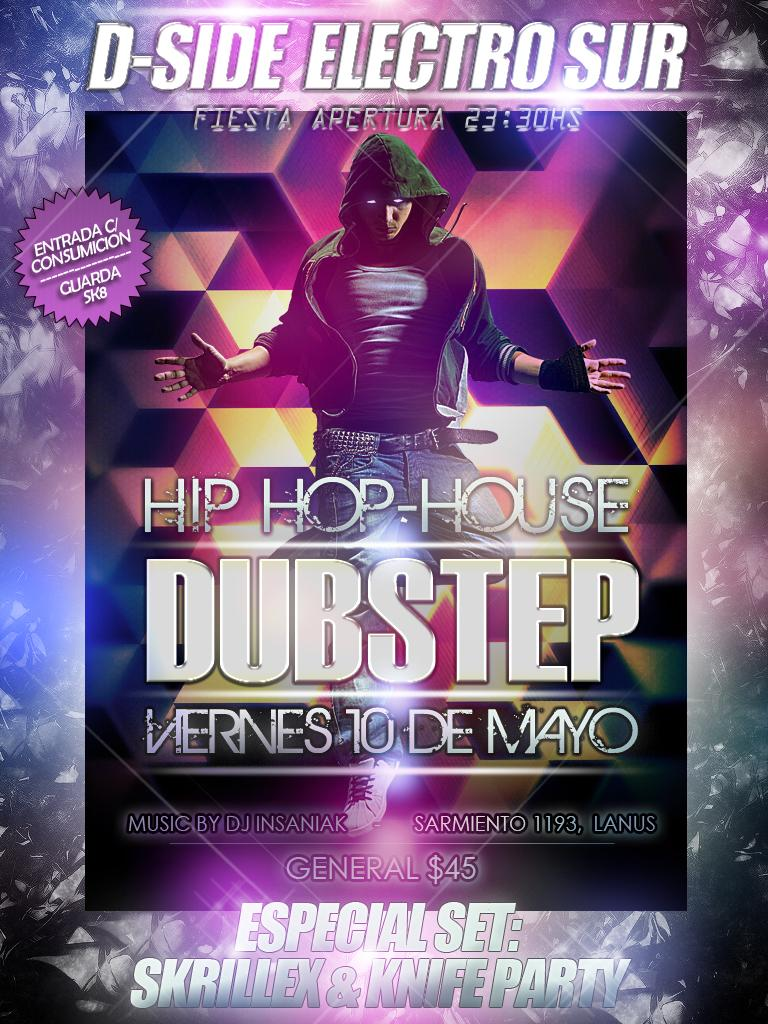<image>
Write a terse but informative summary of the picture. A man with a green hoodie is shown on an ad for Hip Hop-House Dubstep. 